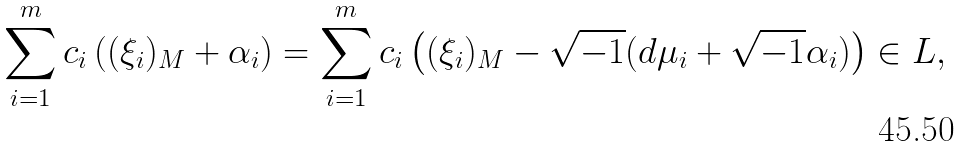Convert formula to latex. <formula><loc_0><loc_0><loc_500><loc_500>\sum _ { i = 1 } ^ { m } c _ { i } \left ( ( \xi _ { i } ) _ { M } + \alpha _ { i } \right ) = \sum _ { i = 1 } ^ { m } c _ { i } \left ( ( \xi _ { i } ) _ { M } - \sqrt { - 1 } ( d \mu _ { i } + \sqrt { - 1 } \alpha _ { i } ) \right ) \in L ,</formula> 